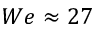Convert formula to latex. <formula><loc_0><loc_0><loc_500><loc_500>W e \approx 2 7</formula> 